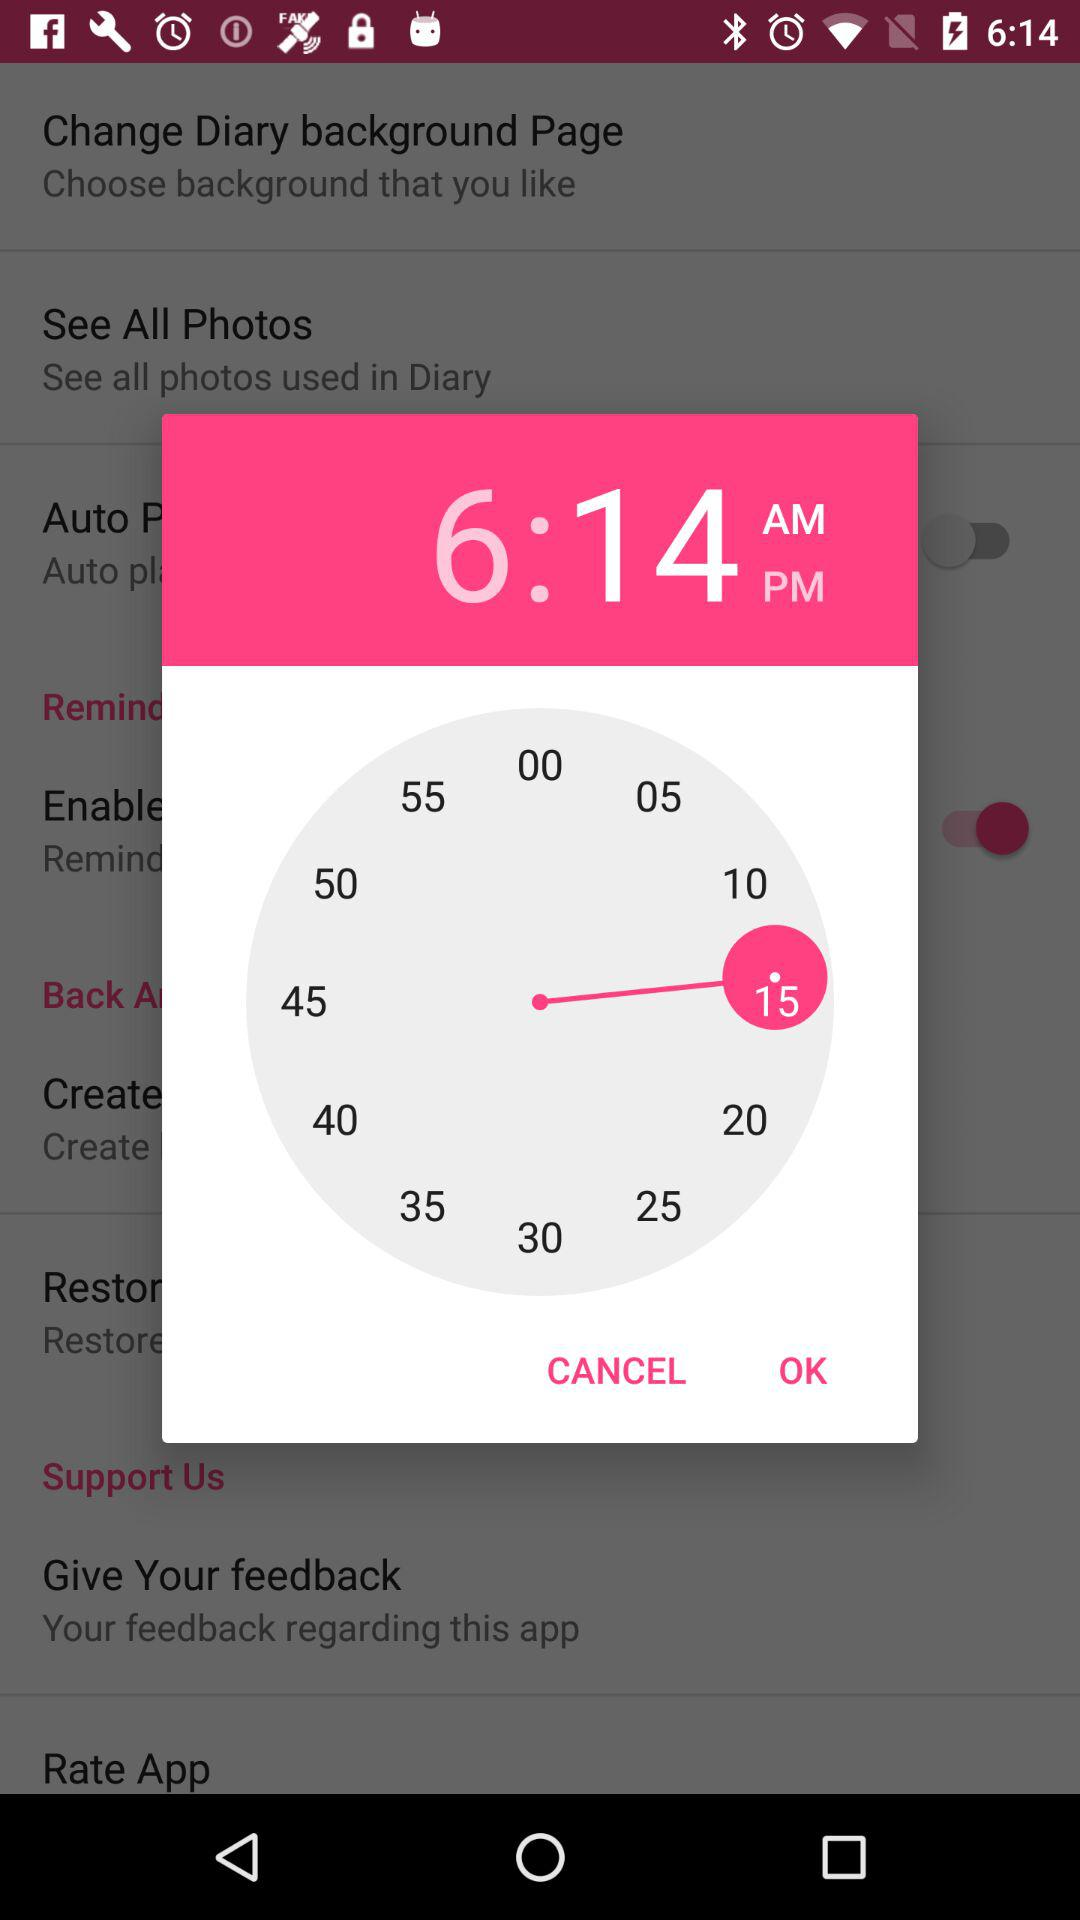What is the time? The time is 6:14 AM. 